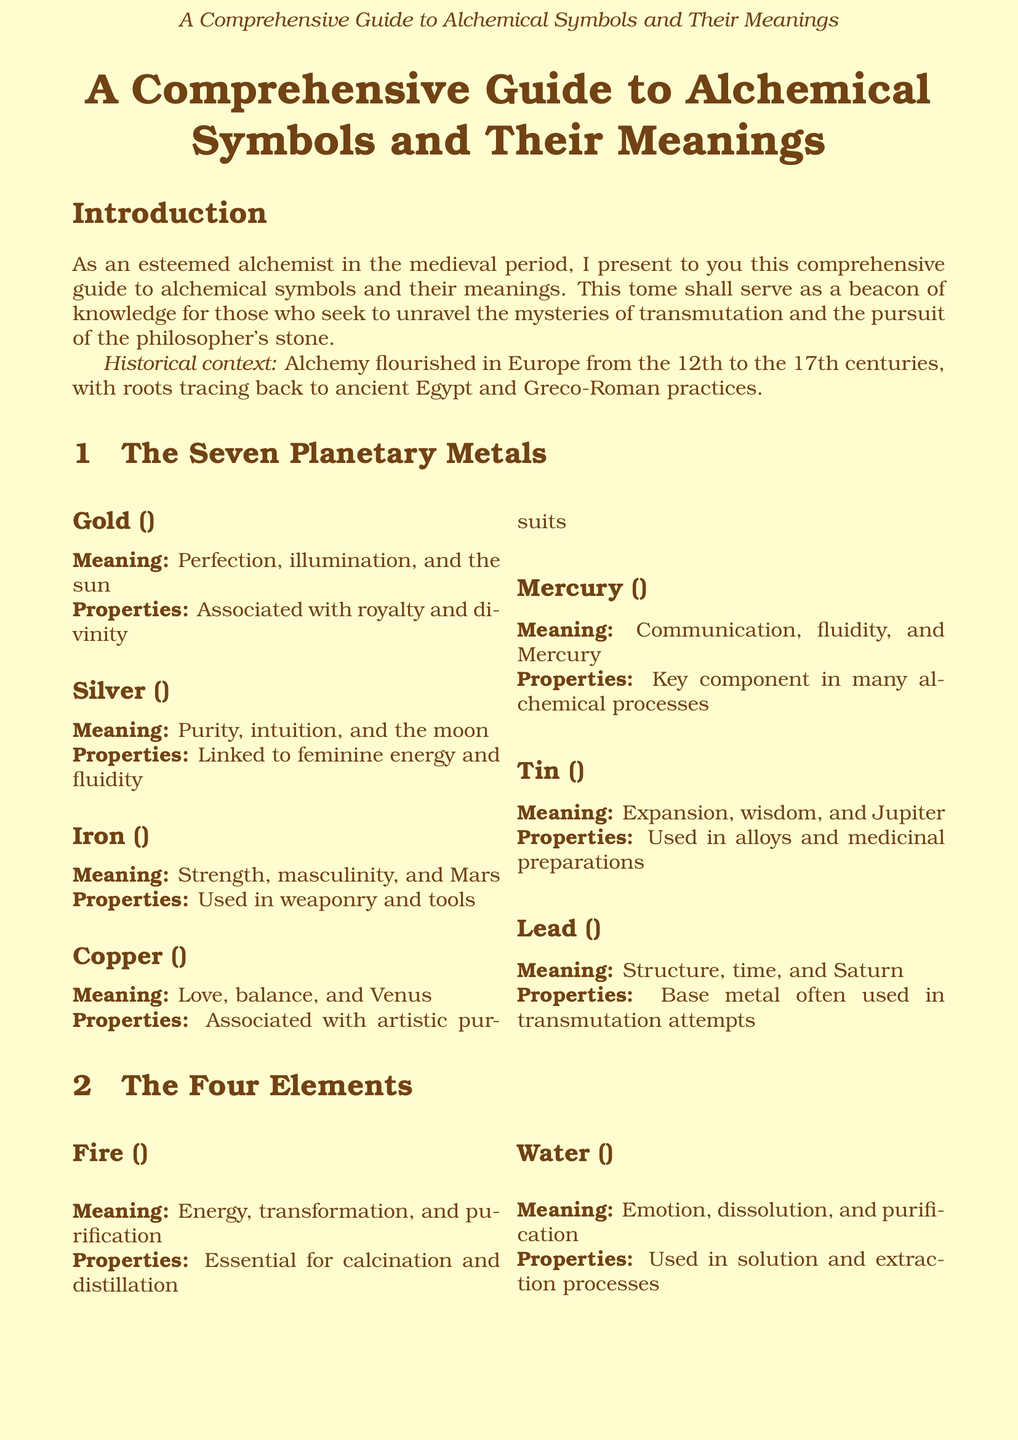What is the meaning of Gold? The meaning of Gold is "Perfection, illumination, and the sun."
Answer: Perfection, illumination, and the sun What element is associated with Water? Water is linked to the meaning "Emotion, dissolution, and purification."
Answer: Emotion, dissolution, and purification Which process involves purification through evaporation and condensation? The document states that "Distillation" refers to purification through evaporation and condensation.
Answer: Distillation What symbol represents the Philosopher's Stone? The Philosopher's Stone is represented by the symbol "☤."
Answer: ☤ How many planetary metals are listed in the document? The document lists a total of seven planetary metals.
Answer: Seven What is the alchemical property of Mercury? The property associated with Mercury is that it is "Key component in many alchemical processes."
Answer: Key component in many alchemical processes What does the symbol for Fire represent? The symbol for Fire represents "Energy, transformation, and purification."
Answer: Energy, transformation, and purification What is the ultimate goal of alchemy? The ultimate goal of alchemy is to achieve the "Philosopher's Stone."
Answer: Philosopher's Stone 